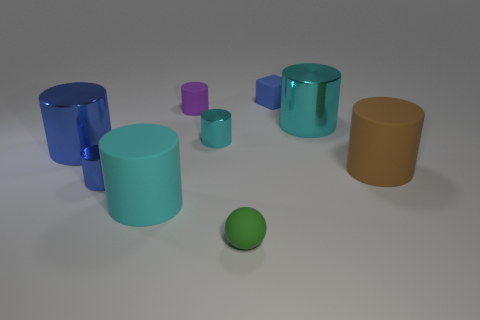Which of these objects is the tallest? The tallest object in the image appears to be the blue cylindrical container on the left. 